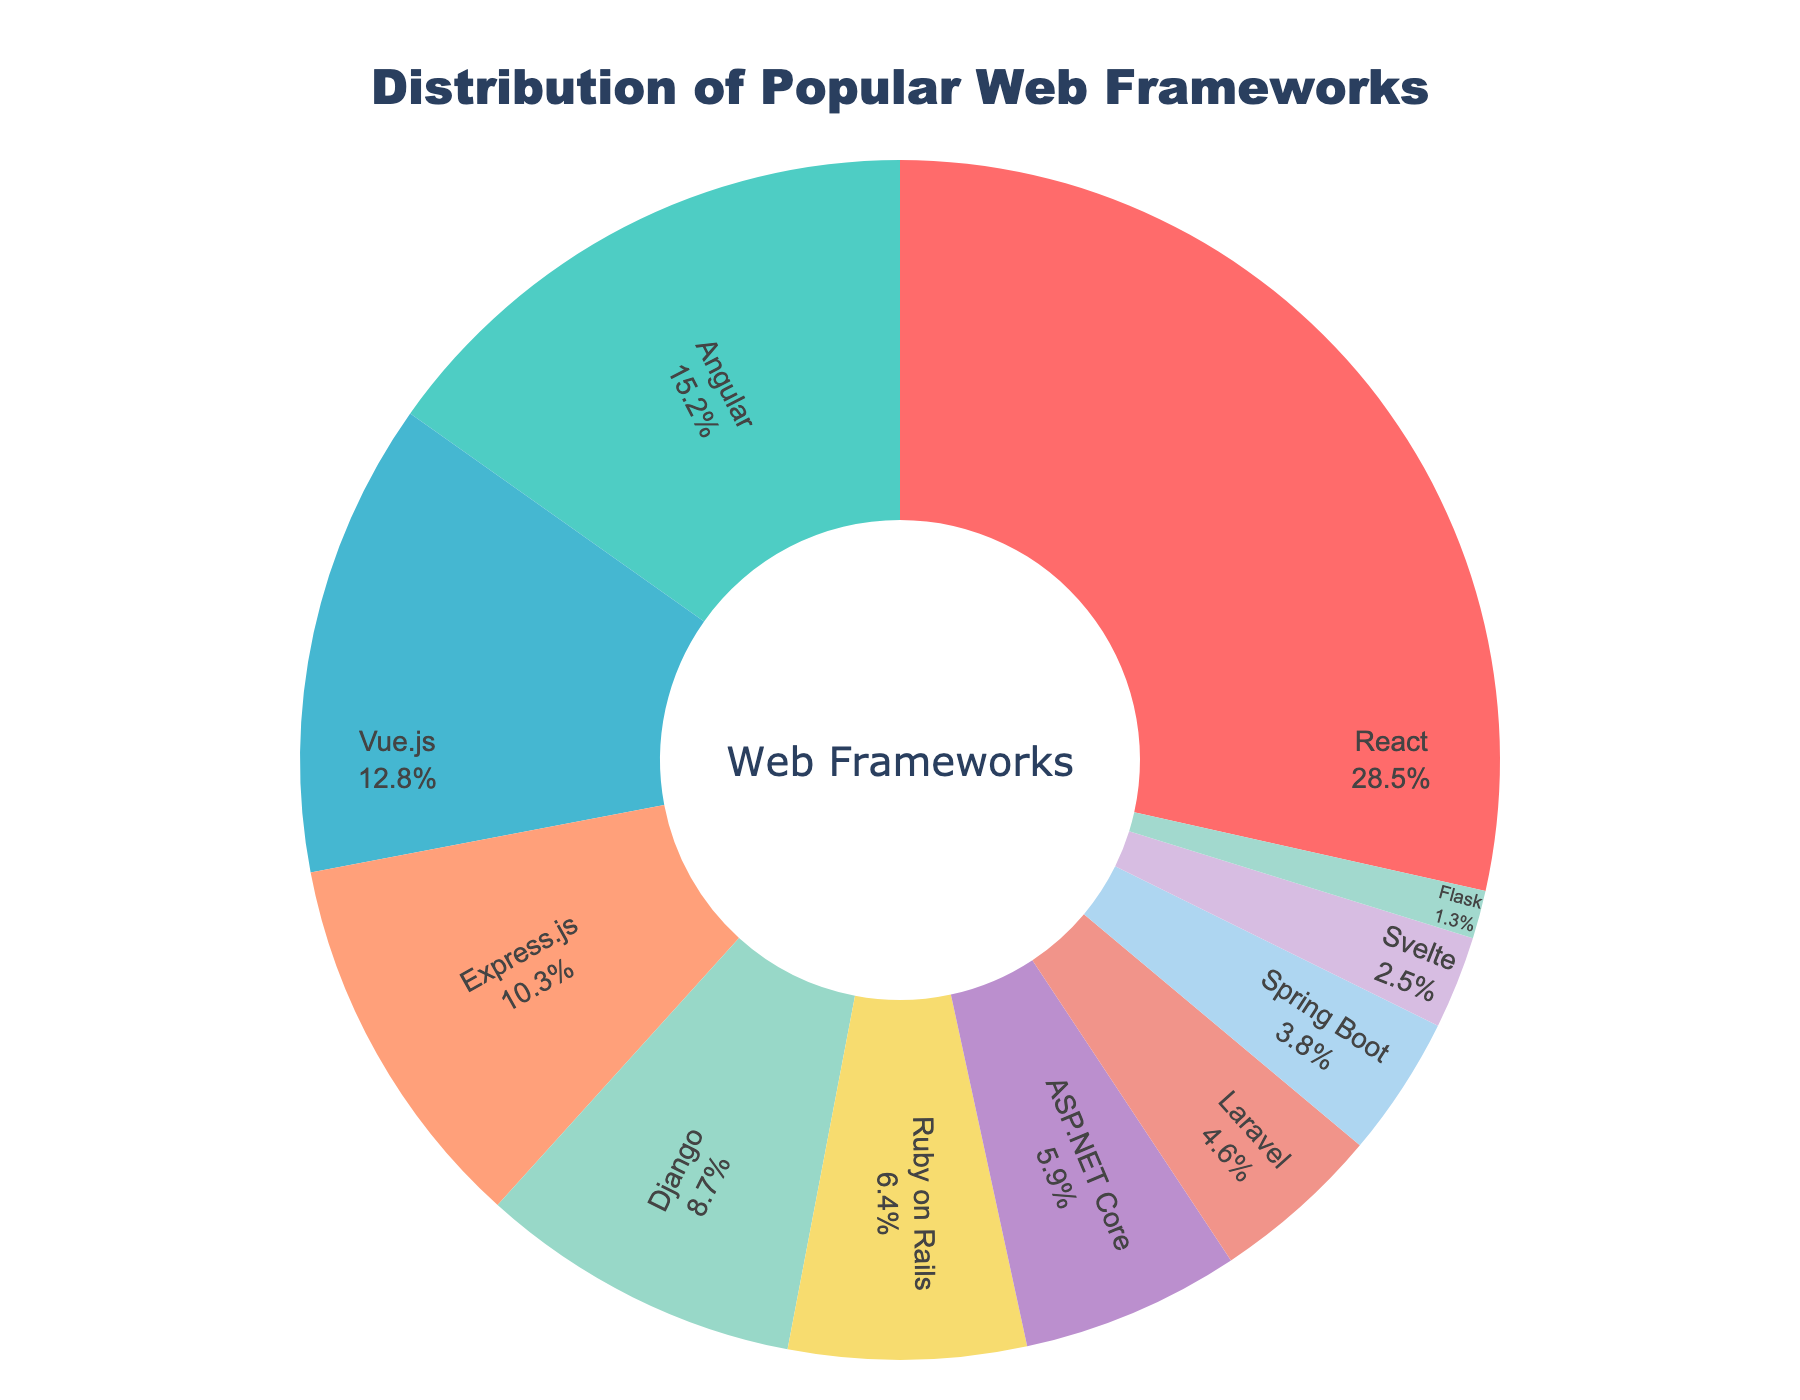How many frameworks together form at least 50% of the distribution? To determine the number of frameworks that form at least 50%, sort the frameworks by percentage in descending order and sum the values until the cumulative percentage exceeds 50%. Summing the percentages for React (28.5%), Angular (15.2%), and Vue.js (12.8%) gives a total of 56.5%, which is over 50%, so 3 frameworks are needed.
Answer: 3 Which framework has the lowest percentage? Identify the framework with the smallest percentage slice in the pie chart. In this case, Flask has 1.3%, which is the smallest percentage.
Answer: Flask Is React more popular than Angular and Django combined? Sum the percentages for Angular (15.2%) and Django (8.7%) and compare this sum to React's percentage. The total is 15.2% + 8.7% = 23.9%, which is less than React's 28.5%.
Answer: Yes What is the percentage difference between Vue.js and Express.js? Subtract the percentage of Express.js (10.3%) from the percentage of Vue.js (12.8%). The difference is 12.8% - 10.3% = 2.5%.
Answer: 2.5% Which frameworks are represented by shades of blue? Identify the portions of the pie chart colored in shades of blue. Express.js (#FFA07A, light salmon) and Svelte (#D7BDE2, light purple) are closest to blue-based colors.
Answer: Express.js, Svelte What is the combined percentage of Flask, Svelte, and Spring Boot? Add the percentages of Flask (1.3%), Svelte (2.5%), and Spring Boot (3.8%). The total is 1.3% + 2.5% + 3.8% = 7.6%.
Answer: 7.6% Which slice appears in green? Identify the portion of the pie chart that is shaded in green. The green color corresponds to Angular.
Answer: Angular 